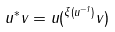<formula> <loc_0><loc_0><loc_500><loc_500>u ^ { * } v = u ( ^ { \xi ( u ^ { - 1 } ) } v )</formula> 